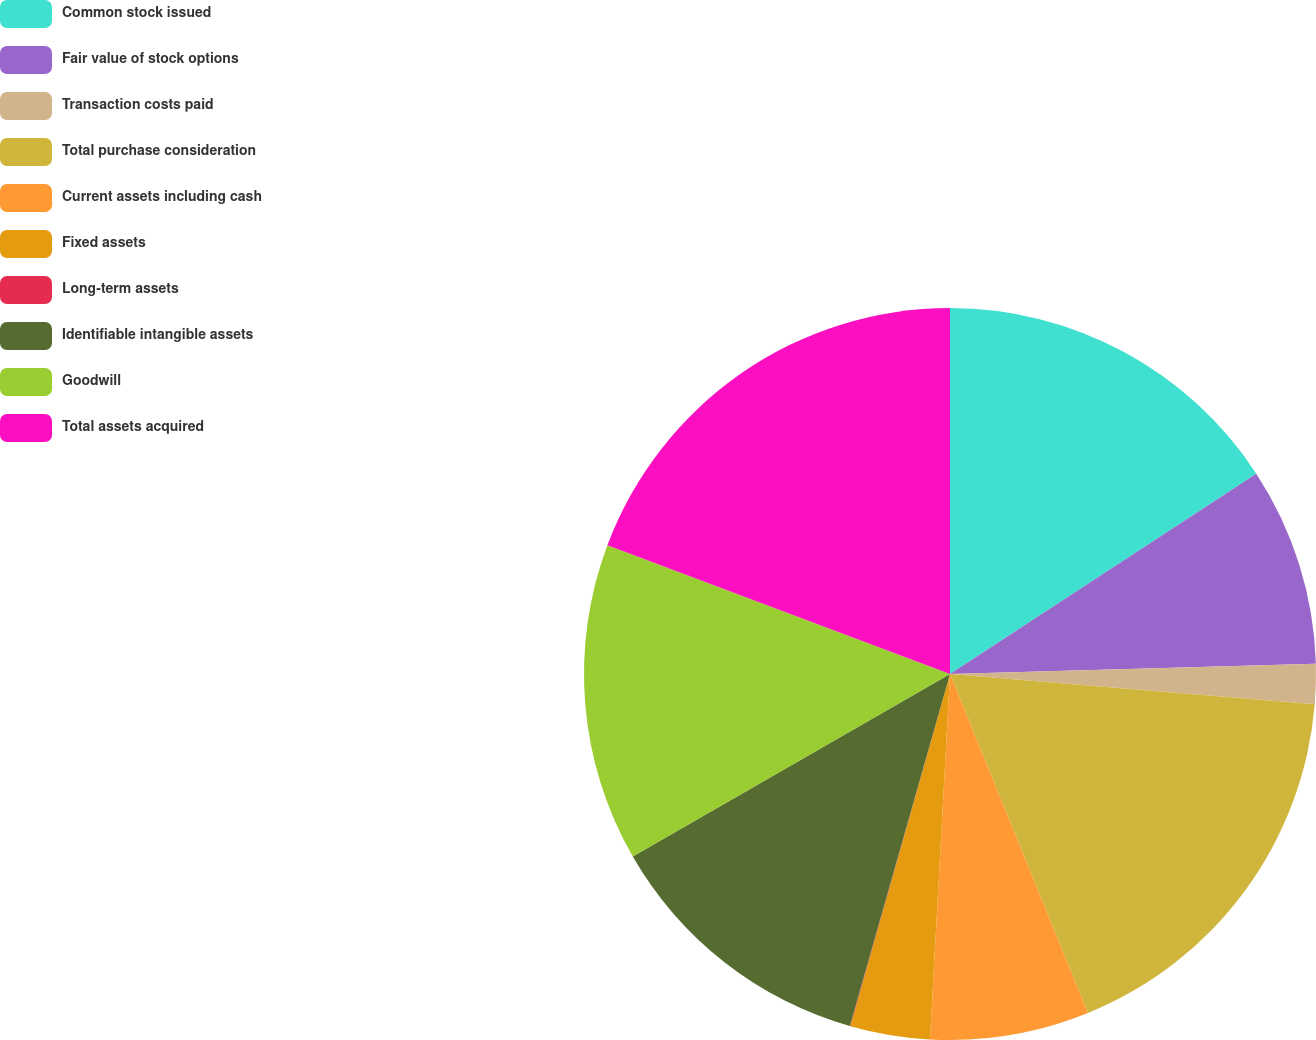Convert chart to OTSL. <chart><loc_0><loc_0><loc_500><loc_500><pie_chart><fcel>Common stock issued<fcel>Fair value of stock options<fcel>Transaction costs paid<fcel>Total purchase consideration<fcel>Current assets including cash<fcel>Fixed assets<fcel>Long-term assets<fcel>Identifiable intangible assets<fcel>Goodwill<fcel>Total assets acquired<nl><fcel>15.78%<fcel>8.77%<fcel>1.77%<fcel>17.53%<fcel>7.02%<fcel>3.52%<fcel>0.02%<fcel>12.28%<fcel>14.03%<fcel>19.28%<nl></chart> 